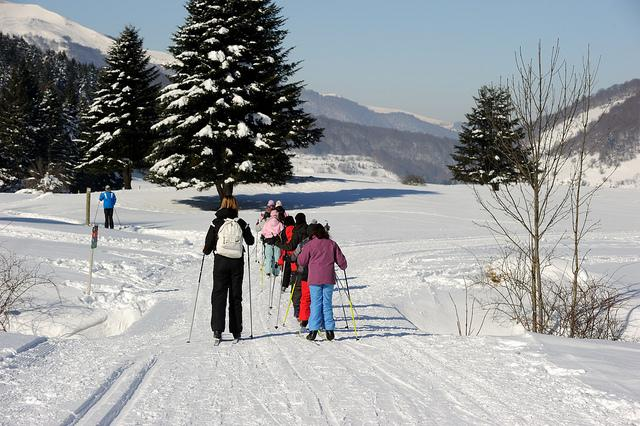What kind of terrain is best for this activity? snow 